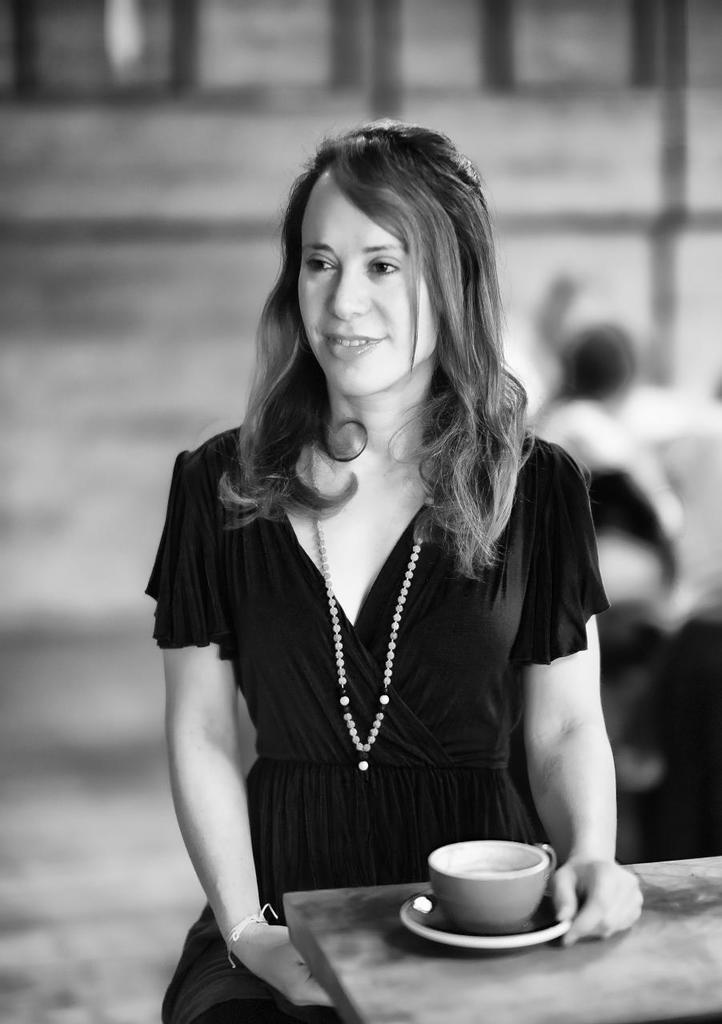What is the primary subject of the image? There is a woman standing in the image. What is the woman doing in the image? The woman is laughing. Can you describe any objects in the image? There is a cup on a table in the image. What type of knowledge can be seen being shared in the image? There is no indication of knowledge being shared in the image; it primarily features a woman laughing. 